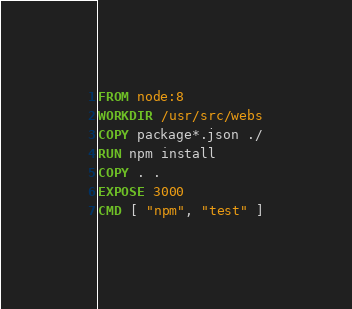Convert code to text. <code><loc_0><loc_0><loc_500><loc_500><_Dockerfile_>FROM node:8
WORKDIR /usr/src/webs
COPY package*.json ./
RUN npm install
COPY . .
EXPOSE 3000
CMD [ "npm", "test" ]
</code> 